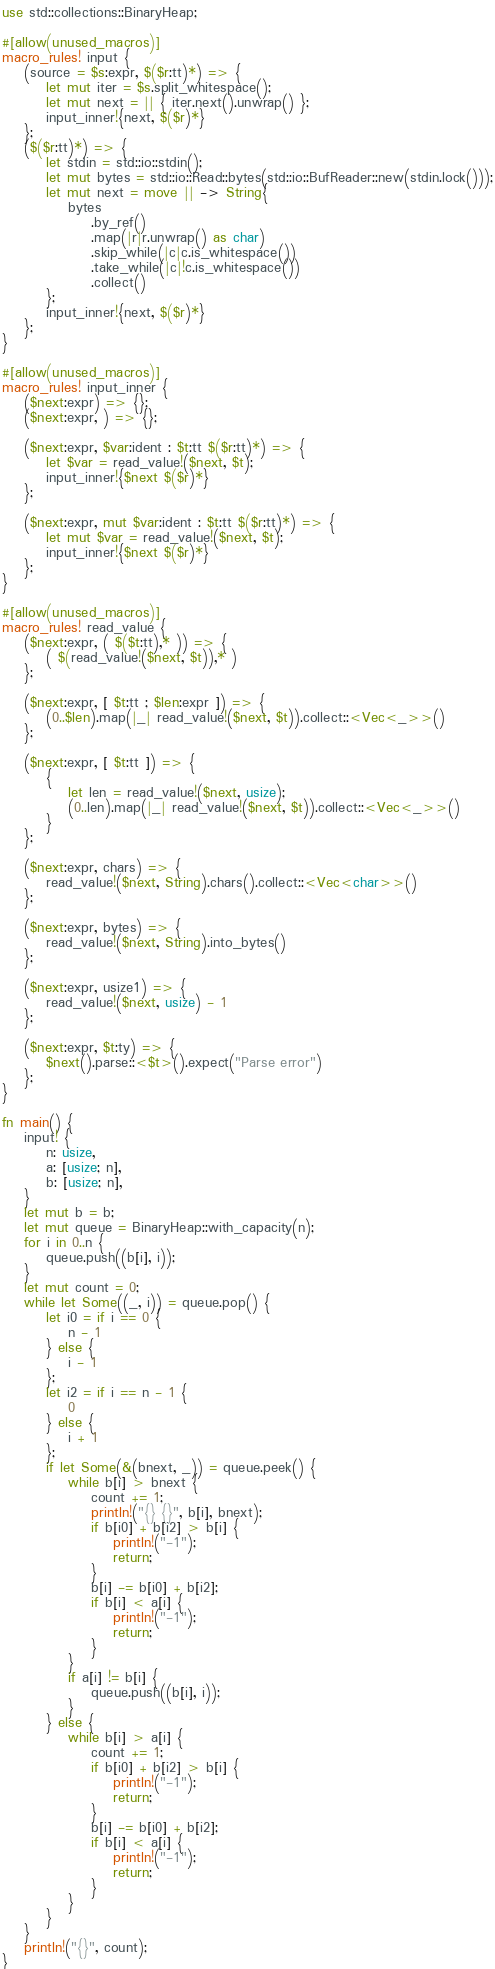<code> <loc_0><loc_0><loc_500><loc_500><_Rust_>use std::collections::BinaryHeap;

#[allow(unused_macros)]
macro_rules! input {
    (source = $s:expr, $($r:tt)*) => {
        let mut iter = $s.split_whitespace();
        let mut next = || { iter.next().unwrap() };
        input_inner!{next, $($r)*}
    };
    ($($r:tt)*) => {
        let stdin = std::io::stdin();
        let mut bytes = std::io::Read::bytes(std::io::BufReader::new(stdin.lock()));
        let mut next = move || -> String{
            bytes
                .by_ref()
                .map(|r|r.unwrap() as char)
                .skip_while(|c|c.is_whitespace())
                .take_while(|c|!c.is_whitespace())
                .collect()
        };
        input_inner!{next, $($r)*}
    };
}

#[allow(unused_macros)]
macro_rules! input_inner {
    ($next:expr) => {};
    ($next:expr, ) => {};

    ($next:expr, $var:ident : $t:tt $($r:tt)*) => {
        let $var = read_value!($next, $t);
        input_inner!{$next $($r)*}
    };

    ($next:expr, mut $var:ident : $t:tt $($r:tt)*) => {
        let mut $var = read_value!($next, $t);
        input_inner!{$next $($r)*}
    };
}

#[allow(unused_macros)]
macro_rules! read_value {
    ($next:expr, ( $($t:tt),* )) => {
        ( $(read_value!($next, $t)),* )
    };

    ($next:expr, [ $t:tt ; $len:expr ]) => {
        (0..$len).map(|_| read_value!($next, $t)).collect::<Vec<_>>()
    };

    ($next:expr, [ $t:tt ]) => {
        {
            let len = read_value!($next, usize);
            (0..len).map(|_| read_value!($next, $t)).collect::<Vec<_>>()
        }
    };

    ($next:expr, chars) => {
        read_value!($next, String).chars().collect::<Vec<char>>()
    };

    ($next:expr, bytes) => {
        read_value!($next, String).into_bytes()
    };

    ($next:expr, usize1) => {
        read_value!($next, usize) - 1
    };

    ($next:expr, $t:ty) => {
        $next().parse::<$t>().expect("Parse error")
    };
}

fn main() {
    input! {
        n: usize,
        a: [usize; n],
        b: [usize; n],
    }
    let mut b = b;
    let mut queue = BinaryHeap::with_capacity(n);
    for i in 0..n {
        queue.push((b[i], i));
    }
    let mut count = 0;
    while let Some((_, i)) = queue.pop() {
        let i0 = if i == 0 {
            n - 1
        } else {
            i - 1
        };
        let i2 = if i == n - 1 {
            0
        } else {
            i + 1
        };
        if let Some(&(bnext, _)) = queue.peek() {
            while b[i] > bnext {
                count += 1;
                println!("{} {}", b[i], bnext);
                if b[i0] + b[i2] > b[i] {
                    println!("-1");
                    return;
                }
                b[i] -= b[i0] + b[i2];
                if b[i] < a[i] {
                    println!("-1");
                    return;
                }
            }
            if a[i] != b[i] {
                queue.push((b[i], i));
            }
        } else {
            while b[i] > a[i] {
                count += 1;
                if b[i0] + b[i2] > b[i] {
                    println!("-1");
                    return;
                }
                b[i] -= b[i0] + b[i2];
                if b[i] < a[i] {
                    println!("-1");
                    return;
                }
            }
        }
    }
    println!("{}", count);
}

</code> 